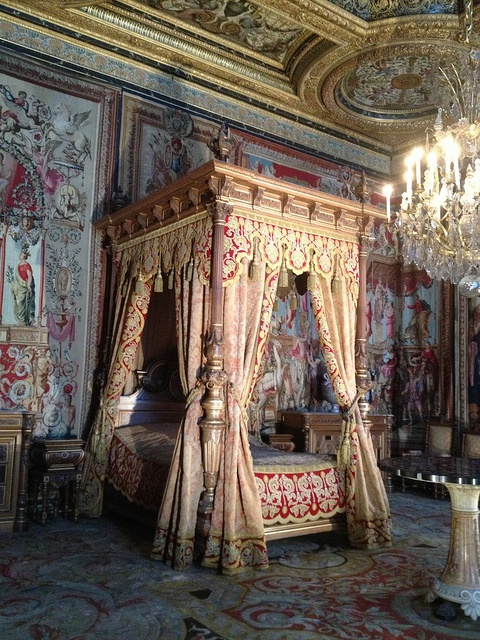Describe the objects in this image and their specific colors. I can see bed in gray, black, and tan tones, chair in gray and black tones, and chair in gray and black tones in this image. 